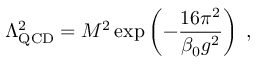<formula> <loc_0><loc_0><loc_500><loc_500>\Lambda _ { Q C D } ^ { 2 } = M ^ { 2 } \exp \left ( - \frac { 1 6 \pi ^ { 2 } } { \beta _ { 0 } g ^ { 2 } } \right ) \, ,</formula> 